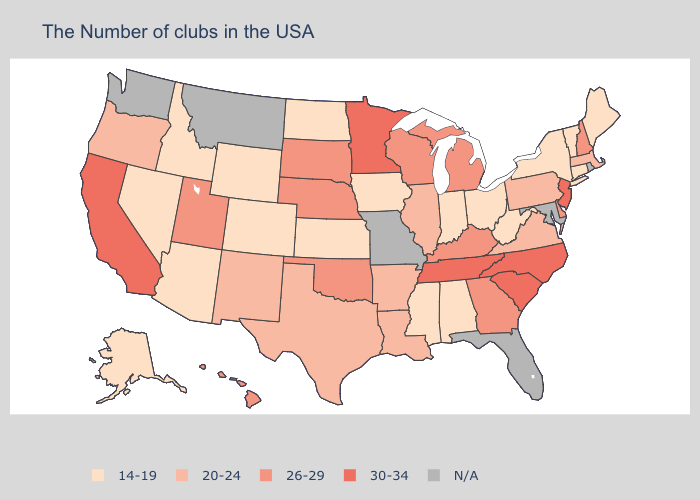What is the lowest value in the USA?
Concise answer only. 14-19. What is the lowest value in the South?
Be succinct. 14-19. Does the first symbol in the legend represent the smallest category?
Short answer required. Yes. Name the states that have a value in the range 20-24?
Short answer required. Massachusetts, Pennsylvania, Virginia, Illinois, Louisiana, Arkansas, Texas, New Mexico, Oregon. What is the lowest value in the USA?
Concise answer only. 14-19. Name the states that have a value in the range 26-29?
Concise answer only. New Hampshire, Delaware, Georgia, Michigan, Kentucky, Wisconsin, Nebraska, Oklahoma, South Dakota, Utah, Hawaii. What is the value of Oregon?
Quick response, please. 20-24. Among the states that border Delaware , which have the highest value?
Write a very short answer. New Jersey. What is the value of Mississippi?
Concise answer only. 14-19. Name the states that have a value in the range 20-24?
Keep it brief. Massachusetts, Pennsylvania, Virginia, Illinois, Louisiana, Arkansas, Texas, New Mexico, Oregon. What is the value of Oregon?
Answer briefly. 20-24. Among the states that border California , does Oregon have the highest value?
Write a very short answer. Yes. Name the states that have a value in the range 26-29?
Short answer required. New Hampshire, Delaware, Georgia, Michigan, Kentucky, Wisconsin, Nebraska, Oklahoma, South Dakota, Utah, Hawaii. What is the value of Illinois?
Write a very short answer. 20-24. 